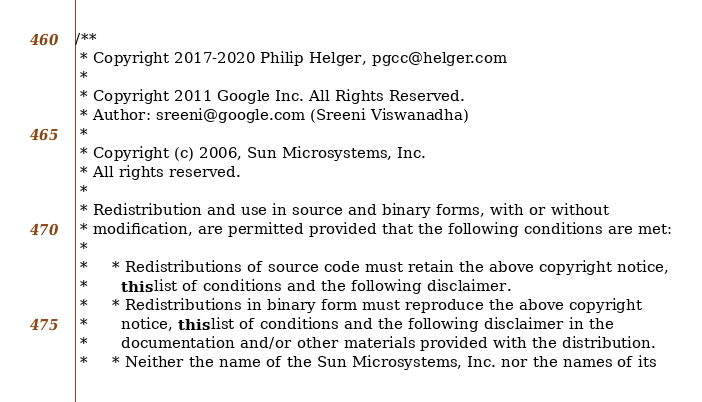Convert code to text. <code><loc_0><loc_0><loc_500><loc_500><_Java_>/**
 * Copyright 2017-2020 Philip Helger, pgcc@helger.com
 *
 * Copyright 2011 Google Inc. All Rights Reserved.
 * Author: sreeni@google.com (Sreeni Viswanadha)
 *
 * Copyright (c) 2006, Sun Microsystems, Inc.
 * All rights reserved.
 *
 * Redistribution and use in source and binary forms, with or without
 * modification, are permitted provided that the following conditions are met:
 *
 *     * Redistributions of source code must retain the above copyright notice,
 *       this list of conditions and the following disclaimer.
 *     * Redistributions in binary form must reproduce the above copyright
 *       notice, this list of conditions and the following disclaimer in the
 *       documentation and/or other materials provided with the distribution.
 *     * Neither the name of the Sun Microsystems, Inc. nor the names of its</code> 